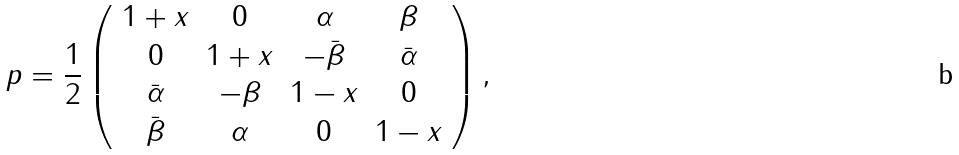Convert formula to latex. <formula><loc_0><loc_0><loc_500><loc_500>p = \frac { 1 } { 2 } \left ( \begin{array} { c c c c } 1 + x & 0 & \alpha & \beta \\ 0 & 1 + x & - \bar { \beta } & \bar { \alpha } \\ \bar { \alpha } & - \beta & 1 - x & 0 \\ \bar { \beta } & \alpha & 0 & 1 - x \end{array} \right ) ,</formula> 